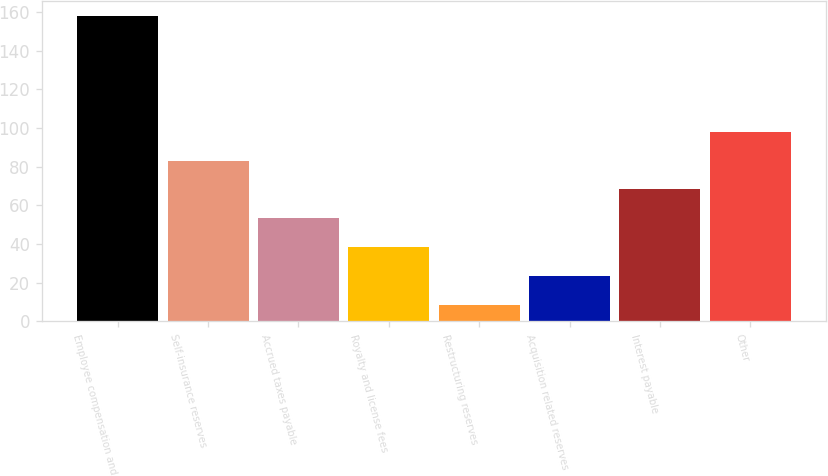<chart> <loc_0><loc_0><loc_500><loc_500><bar_chart><fcel>Employee compensation and<fcel>Self-insurance reserves<fcel>Accrued taxes payable<fcel>Royalty and license fees<fcel>Restructuring reserves<fcel>Acquisition related reserves<fcel>Interest payable<fcel>Other<nl><fcel>158<fcel>83.2<fcel>53.28<fcel>38.32<fcel>8.4<fcel>23.36<fcel>68.24<fcel>98.16<nl></chart> 